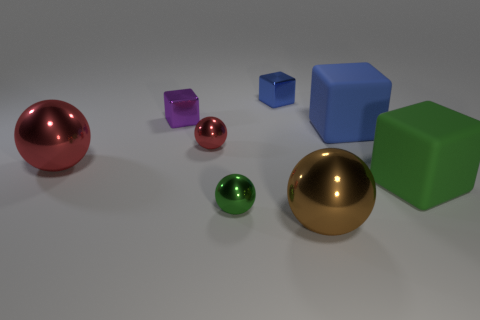How many things are either green spheres or blue matte cylinders?
Your answer should be very brief. 1. What number of big blue things are in front of the small ball that is to the left of the small metal object that is in front of the big green block?
Offer a terse response. 0. Does the large matte cube in front of the tiny red shiny object have the same color as the sphere that is behind the large red sphere?
Make the answer very short. No. Are there more green matte blocks on the left side of the brown sphere than large things to the left of the large red object?
Offer a very short reply. No. What material is the purple block?
Your response must be concise. Metal. What shape is the large thing to the left of the large shiny object that is in front of the big metallic thing behind the big brown metal object?
Keep it short and to the point. Sphere. How many other objects are there of the same material as the small red sphere?
Provide a short and direct response. 5. Do the green object behind the small green metal ball and the red sphere that is left of the small red shiny sphere have the same material?
Make the answer very short. No. What number of blocks are both behind the large green rubber block and in front of the tiny purple metallic thing?
Provide a short and direct response. 1. Is there a green rubber thing that has the same shape as the big red thing?
Give a very brief answer. No. 